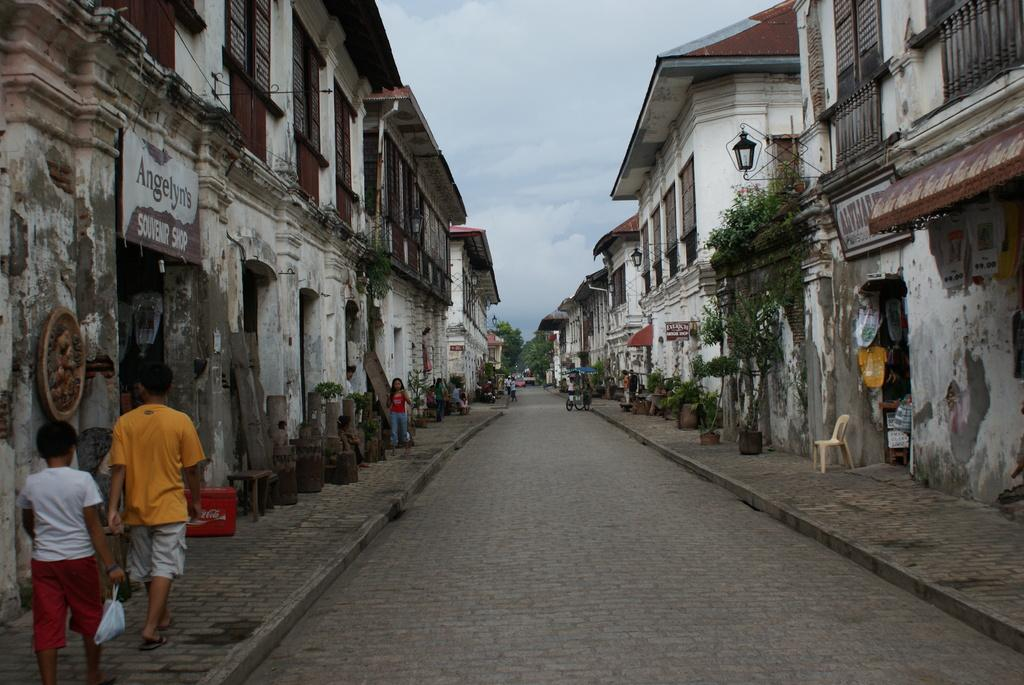What type of structures can be seen in the image? There are buildings in the image. Are there any living beings present in the image? Yes, there are people in the image. What object can be found on the right side of the image? There is a chair on the right side of the image. What mode of transportation is visible in the image? There is a vehicle in the image. What type of natural elements can be seen in the background of the image? There are trees in the background of the image. What part of the natural environment is visible in the background of the image? The sky is visible in the background of the image. Can you tell me how many kites are being flown by the people in the image? There are no kites visible in the image; the people are not flying any kites. What type of oven is present in the image? There is no oven present in the image. 